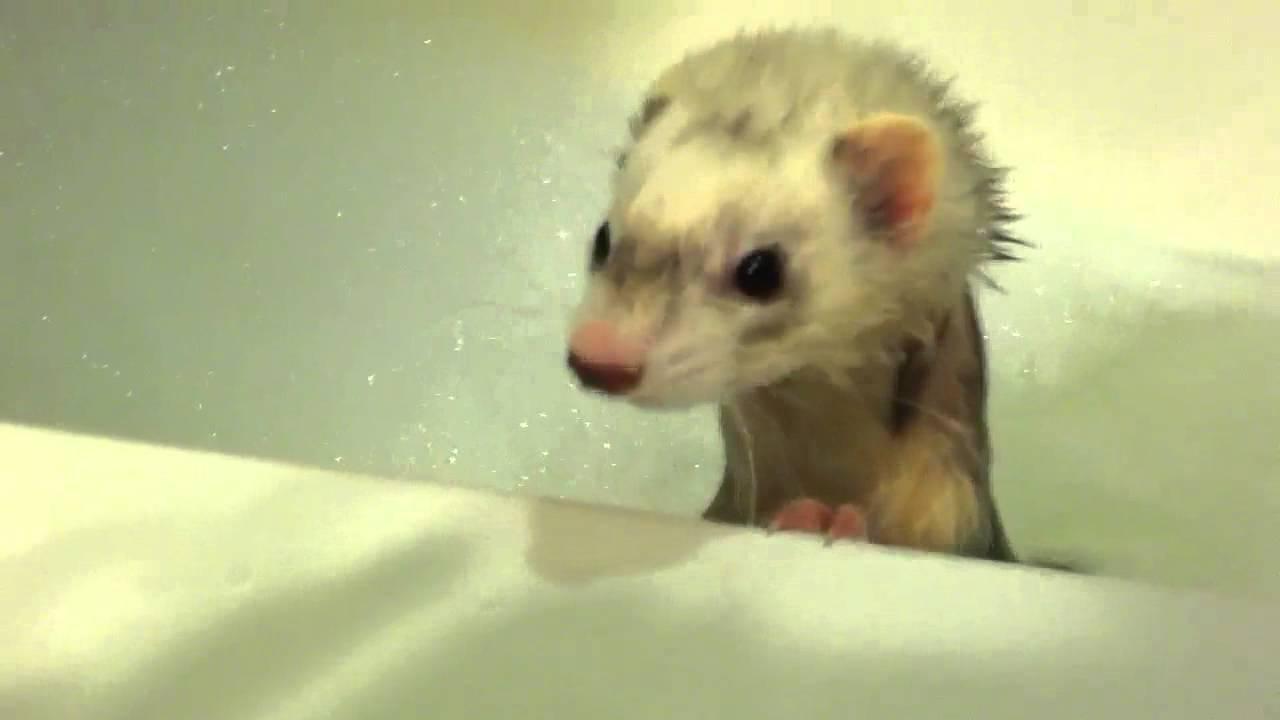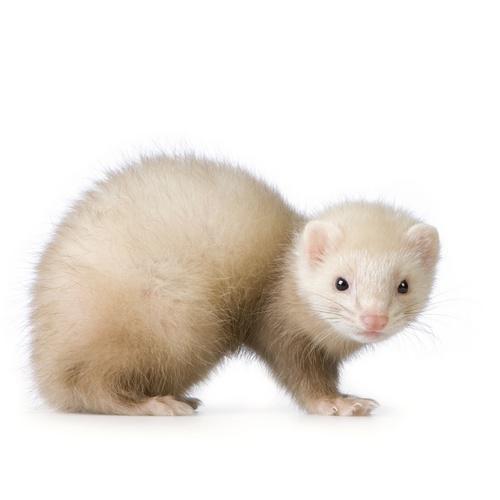The first image is the image on the left, the second image is the image on the right. Analyze the images presented: Is the assertion "One image contains a pair of ferrets." valid? Answer yes or no. No. 